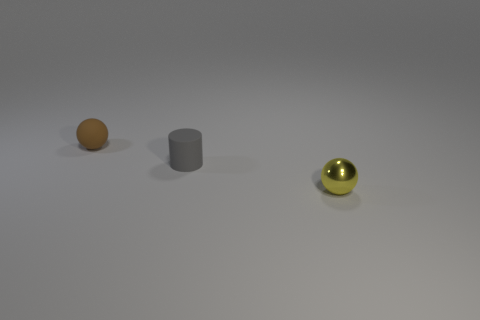Add 2 spheres. How many objects exist? 5 Subtract all balls. How many objects are left? 1 Subtract 2 balls. How many balls are left? 0 Subtract all purple cylinders. How many yellow spheres are left? 1 Subtract all tiny matte spheres. Subtract all gray rubber cylinders. How many objects are left? 1 Add 1 gray cylinders. How many gray cylinders are left? 2 Add 1 small gray cylinders. How many small gray cylinders exist? 2 Subtract 0 green cylinders. How many objects are left? 3 Subtract all cyan cylinders. Subtract all red blocks. How many cylinders are left? 1 